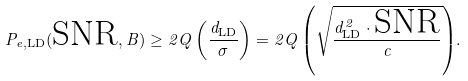Convert formula to latex. <formula><loc_0><loc_0><loc_500><loc_500>P _ { e , \text {LD} } ( \text {SNR} , B ) \geq 2 { Q \left ( \frac { d _ { \text {LD} } } { \sigma } \right ) } = 2 { Q \left ( \sqrt { \frac { d _ { \text {LD} } ^ { 2 } \cdot \text {SNR} } { c } } \right ) } .</formula> 